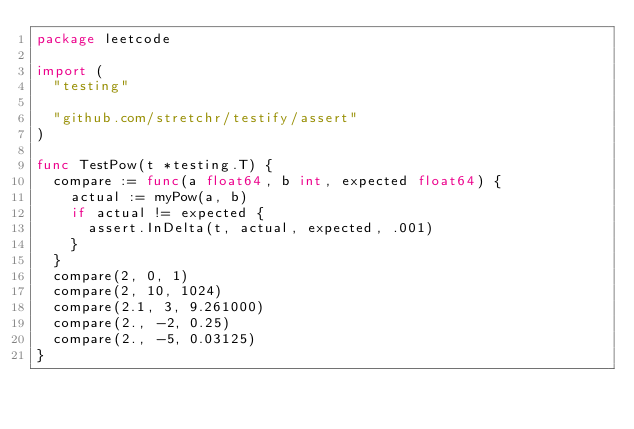<code> <loc_0><loc_0><loc_500><loc_500><_Go_>package leetcode

import (
	"testing"

	"github.com/stretchr/testify/assert"
)

func TestPow(t *testing.T) {
	compare := func(a float64, b int, expected float64) {
		actual := myPow(a, b)
		if actual != expected {
			assert.InDelta(t, actual, expected, .001)
		}
	}
	compare(2, 0, 1)
	compare(2, 10, 1024)
	compare(2.1, 3, 9.261000)
	compare(2., -2, 0.25)
	compare(2., -5, 0.03125)
}
</code> 